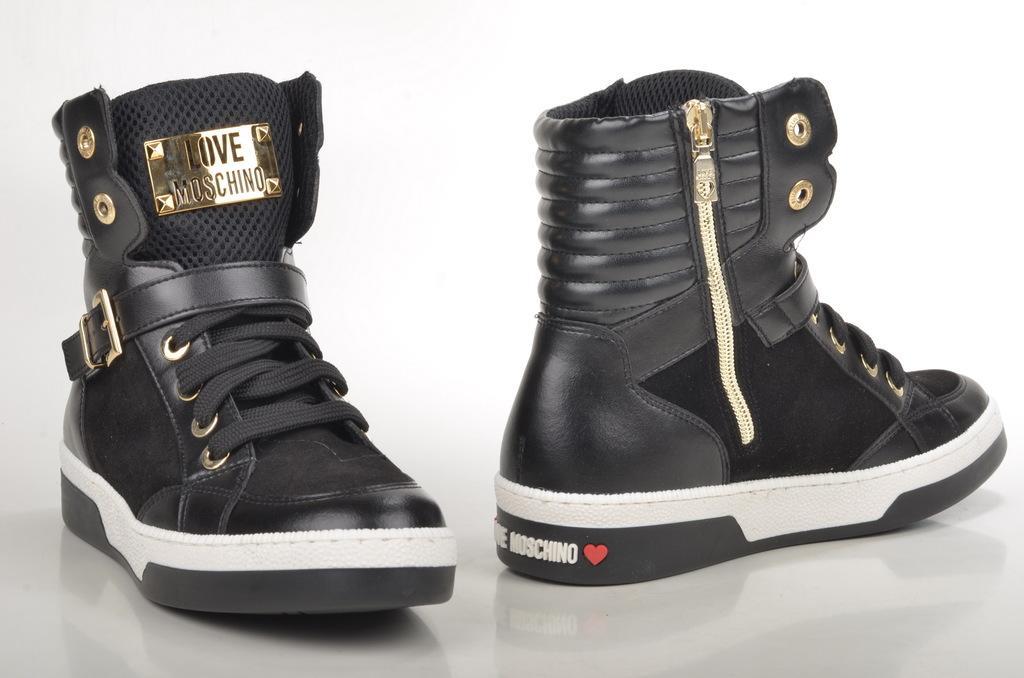How would you summarize this image in a sentence or two? In this image pair of boots are on the floor. Background is in white color. There is some text on the boot which is on the left side of the image. 